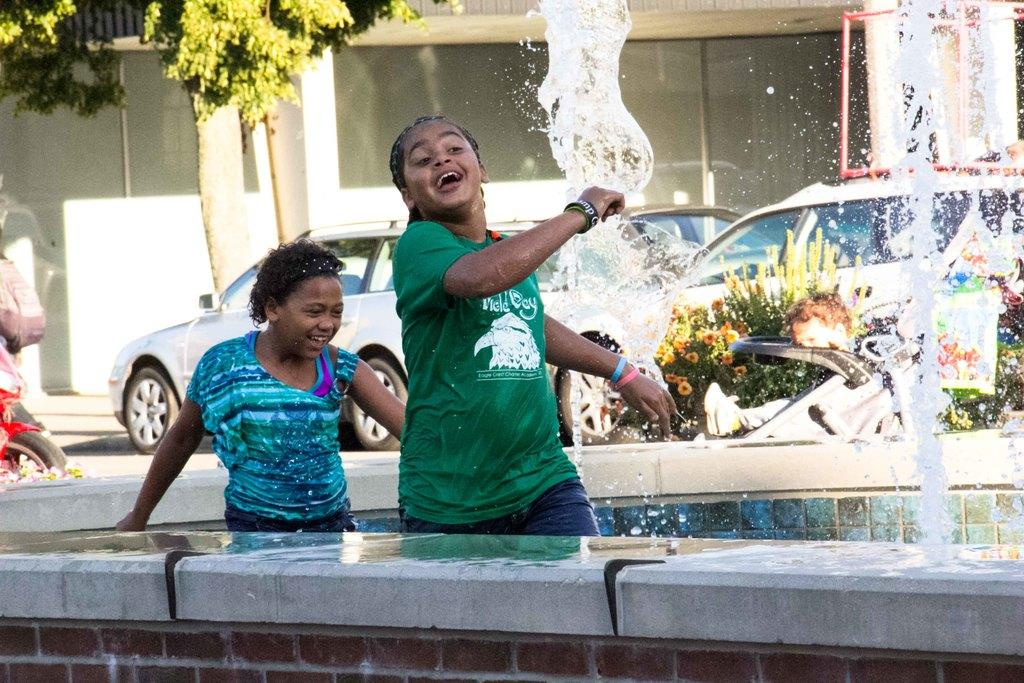How many kids are in the image? There are two kids in the image. What are the kids doing in the image? The kids are playing in a fountain. What can be seen in the background of the image? There is a road, cars, trees, and buildings in the background of the image. What type of tax is being discussed by the kids in the image? There is no indication in the image that the kids are discussing any type of tax. 